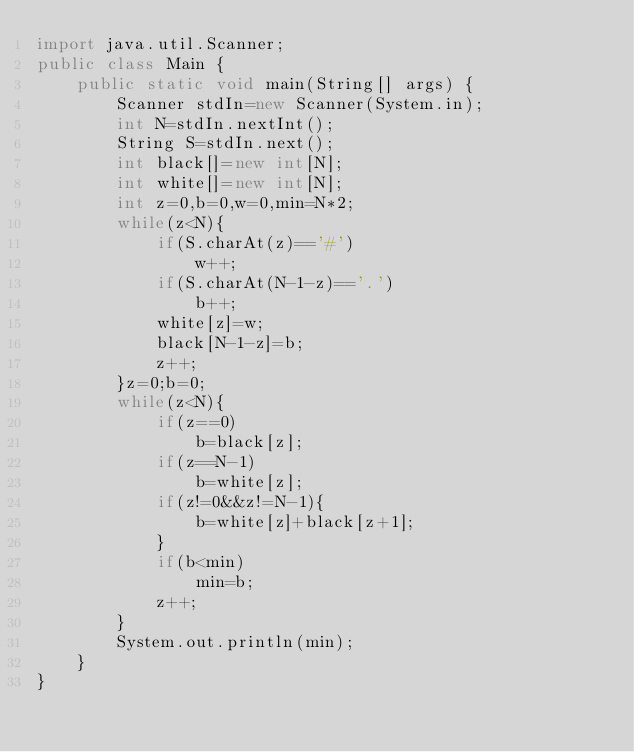<code> <loc_0><loc_0><loc_500><loc_500><_Java_>import java.util.Scanner;
public class Main {
	public static void main(String[] args) {
		Scanner stdIn=new Scanner(System.in);
		int N=stdIn.nextInt();
		String S=stdIn.next();
		int black[]=new int[N];
		int white[]=new int[N];
		int z=0,b=0,w=0,min=N*2;
		while(z<N){
			if(S.charAt(z)=='#')
				w++;
			if(S.charAt(N-1-z)=='.')
				b++;
			white[z]=w;
			black[N-1-z]=b;
			z++;
		}z=0;b=0;
		while(z<N){
			if(z==0)
				b=black[z];
			if(z==N-1)
				b=white[z];
			if(z!=0&&z!=N-1){
				b=white[z]+black[z+1];
			}
			if(b<min)
				min=b;
			z++;
		}
		System.out.println(min);
	}
}
</code> 